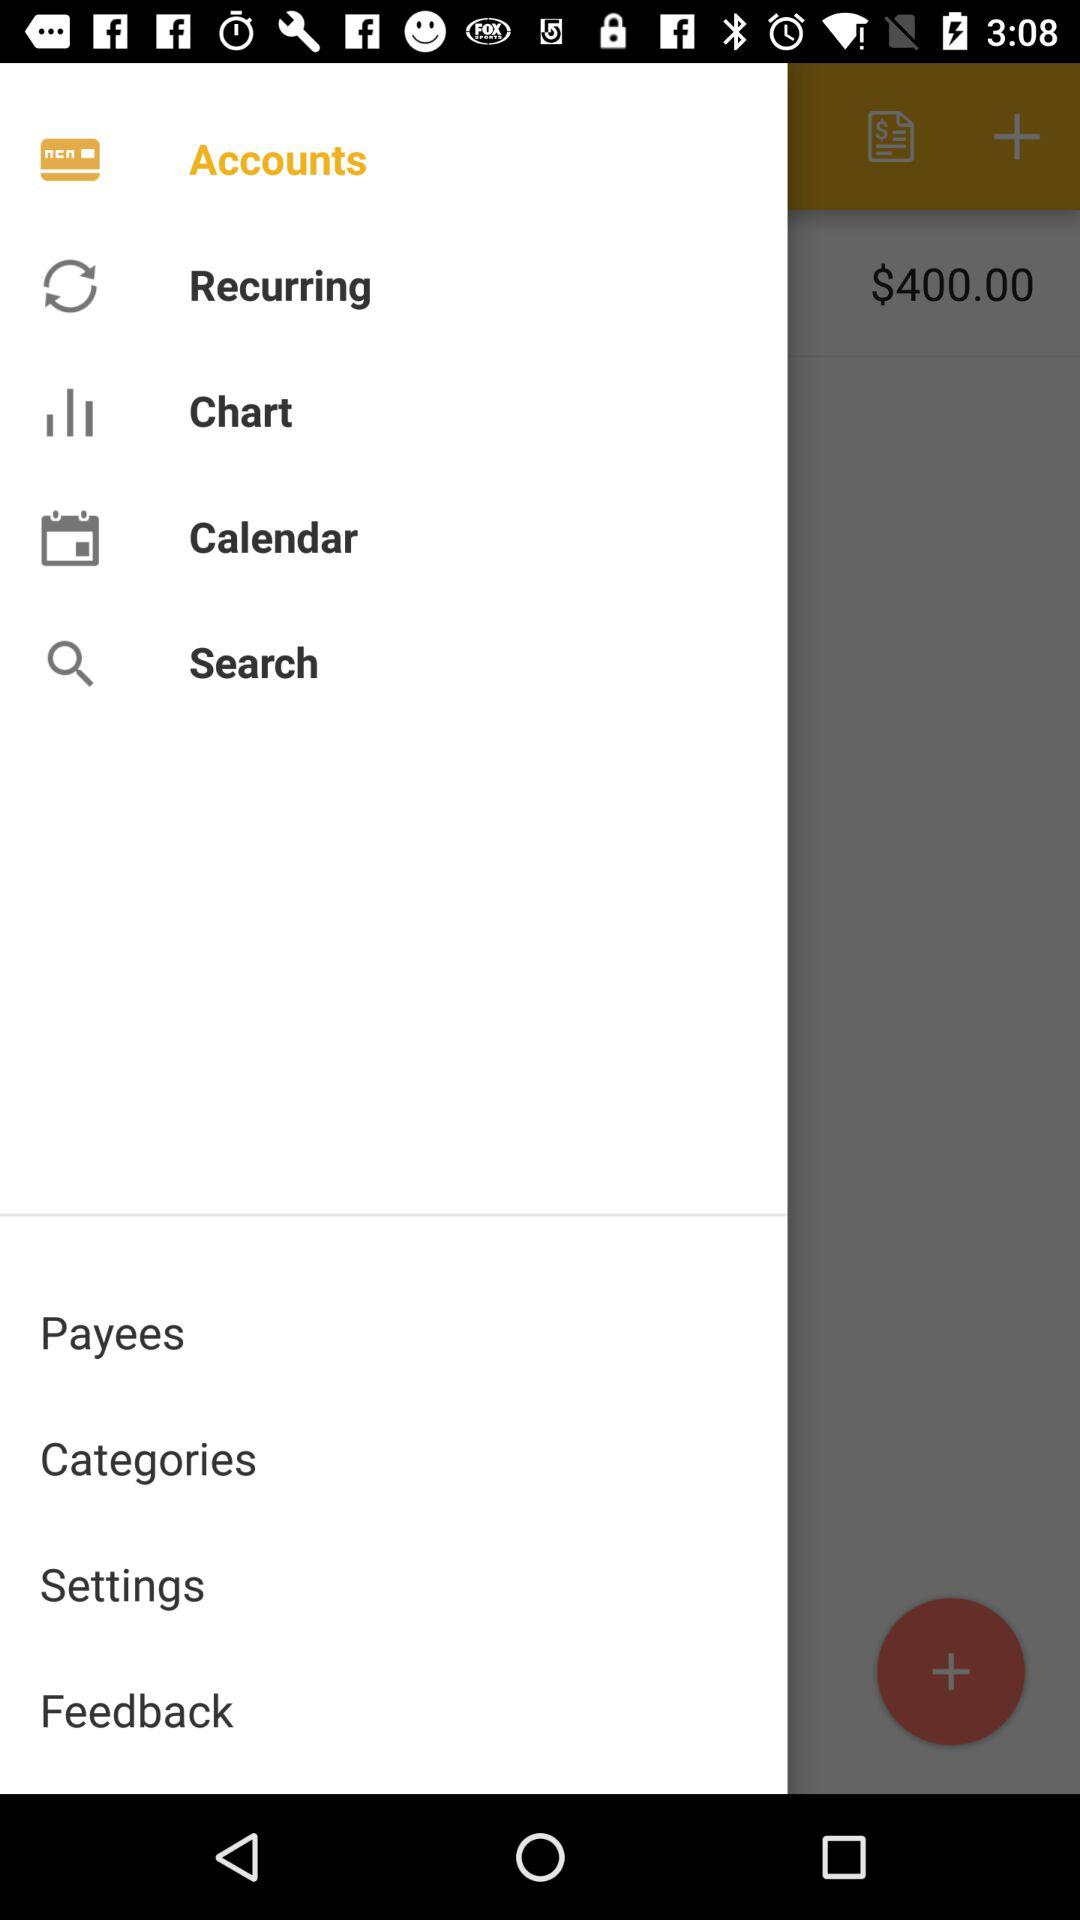How do I add a new transaction in this app? In the displayed mobile banking app, you can add a new transaction by tapping the plus sign button located in the bottom right corner of the screen. This action typically opens a new entry form where you can input details such as the amount, payee, category, and the date of the transaction. 